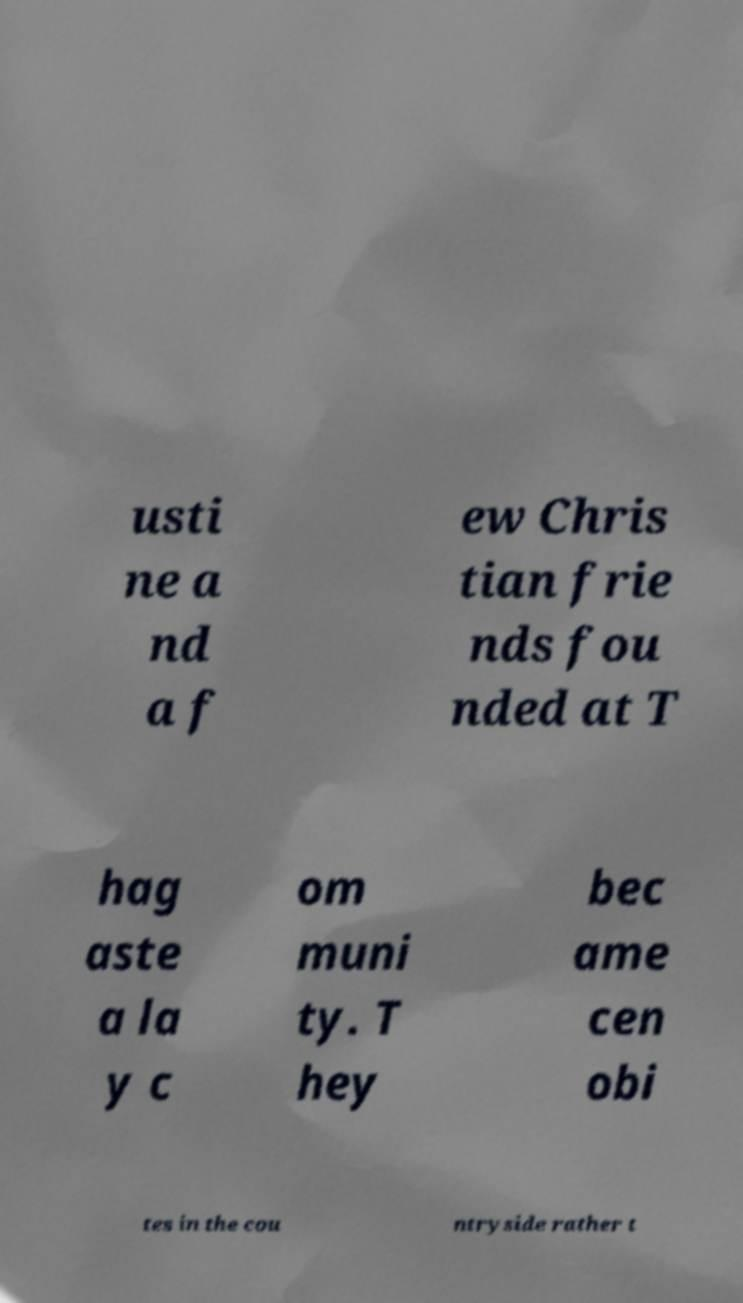Please read and relay the text visible in this image. What does it say? usti ne a nd a f ew Chris tian frie nds fou nded at T hag aste a la y c om muni ty. T hey bec ame cen obi tes in the cou ntryside rather t 